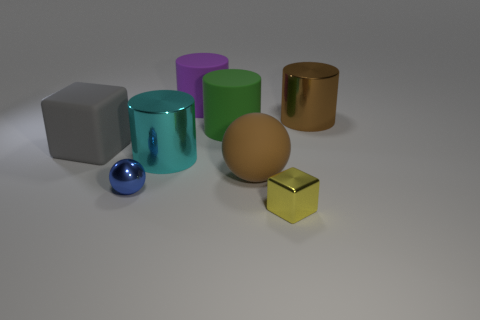Are there an equal number of brown cylinders that are on the left side of the large gray thing and rubber things that are in front of the green matte cylinder?
Give a very brief answer. No. What is the shape of the cyan shiny thing that is the same size as the green matte thing?
Provide a succinct answer. Cylinder. Are there any tiny things of the same color as the small sphere?
Provide a succinct answer. No. There is a large brown object right of the yellow cube; what shape is it?
Provide a succinct answer. Cylinder. The small shiny ball is what color?
Your answer should be very brief. Blue. What is the color of the big block that is made of the same material as the big green cylinder?
Offer a terse response. Gray. What number of yellow things have the same material as the gray block?
Your answer should be very brief. 0. How many small things are behind the small yellow metal cube?
Offer a terse response. 1. Are the large object in front of the cyan object and the block that is on the left side of the large cyan object made of the same material?
Your answer should be compact. Yes. Are there more things that are behind the rubber cube than metal things that are left of the large cyan metallic object?
Your answer should be compact. Yes. 